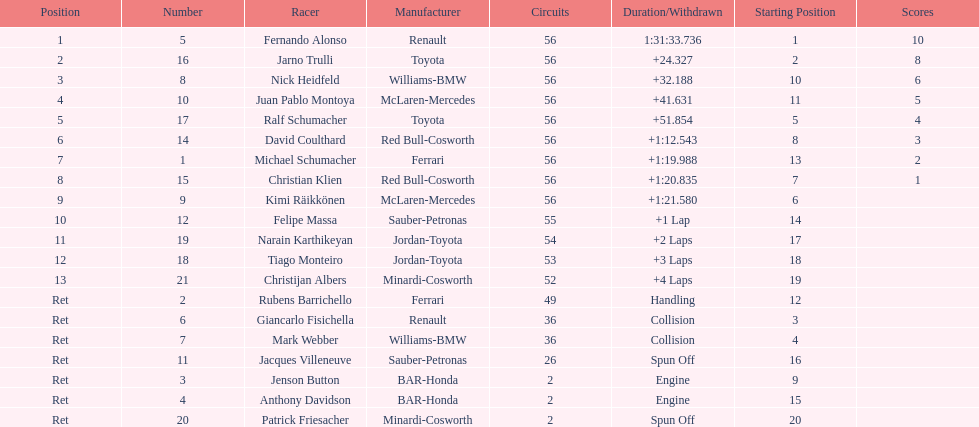Would you mind parsing the complete table? {'header': ['Position', 'Number', 'Racer', 'Manufacturer', 'Circuits', 'Duration/Withdrawn', 'Starting Position', 'Scores'], 'rows': [['1', '5', 'Fernando Alonso', 'Renault', '56', '1:31:33.736', '1', '10'], ['2', '16', 'Jarno Trulli', 'Toyota', '56', '+24.327', '2', '8'], ['3', '8', 'Nick Heidfeld', 'Williams-BMW', '56', '+32.188', '10', '6'], ['4', '10', 'Juan Pablo Montoya', 'McLaren-Mercedes', '56', '+41.631', '11', '5'], ['5', '17', 'Ralf Schumacher', 'Toyota', '56', '+51.854', '5', '4'], ['6', '14', 'David Coulthard', 'Red Bull-Cosworth', '56', '+1:12.543', '8', '3'], ['7', '1', 'Michael Schumacher', 'Ferrari', '56', '+1:19.988', '13', '2'], ['8', '15', 'Christian Klien', 'Red Bull-Cosworth', '56', '+1:20.835', '7', '1'], ['9', '9', 'Kimi Räikkönen', 'McLaren-Mercedes', '56', '+1:21.580', '6', ''], ['10', '12', 'Felipe Massa', 'Sauber-Petronas', '55', '+1 Lap', '14', ''], ['11', '19', 'Narain Karthikeyan', 'Jordan-Toyota', '54', '+2 Laps', '17', ''], ['12', '18', 'Tiago Monteiro', 'Jordan-Toyota', '53', '+3 Laps', '18', ''], ['13', '21', 'Christijan Albers', 'Minardi-Cosworth', '52', '+4 Laps', '19', ''], ['Ret', '2', 'Rubens Barrichello', 'Ferrari', '49', 'Handling', '12', ''], ['Ret', '6', 'Giancarlo Fisichella', 'Renault', '36', 'Collision', '3', ''], ['Ret', '7', 'Mark Webber', 'Williams-BMW', '36', 'Collision', '4', ''], ['Ret', '11', 'Jacques Villeneuve', 'Sauber-Petronas', '26', 'Spun Off', '16', ''], ['Ret', '3', 'Jenson Button', 'BAR-Honda', '2', 'Engine', '9', ''], ['Ret', '4', 'Anthony Davidson', 'BAR-Honda', '2', 'Engine', '15', ''], ['Ret', '20', 'Patrick Friesacher', 'Minardi-Cosworth', '2', 'Spun Off', '20', '']]} How many germans finished in the top five? 2. 